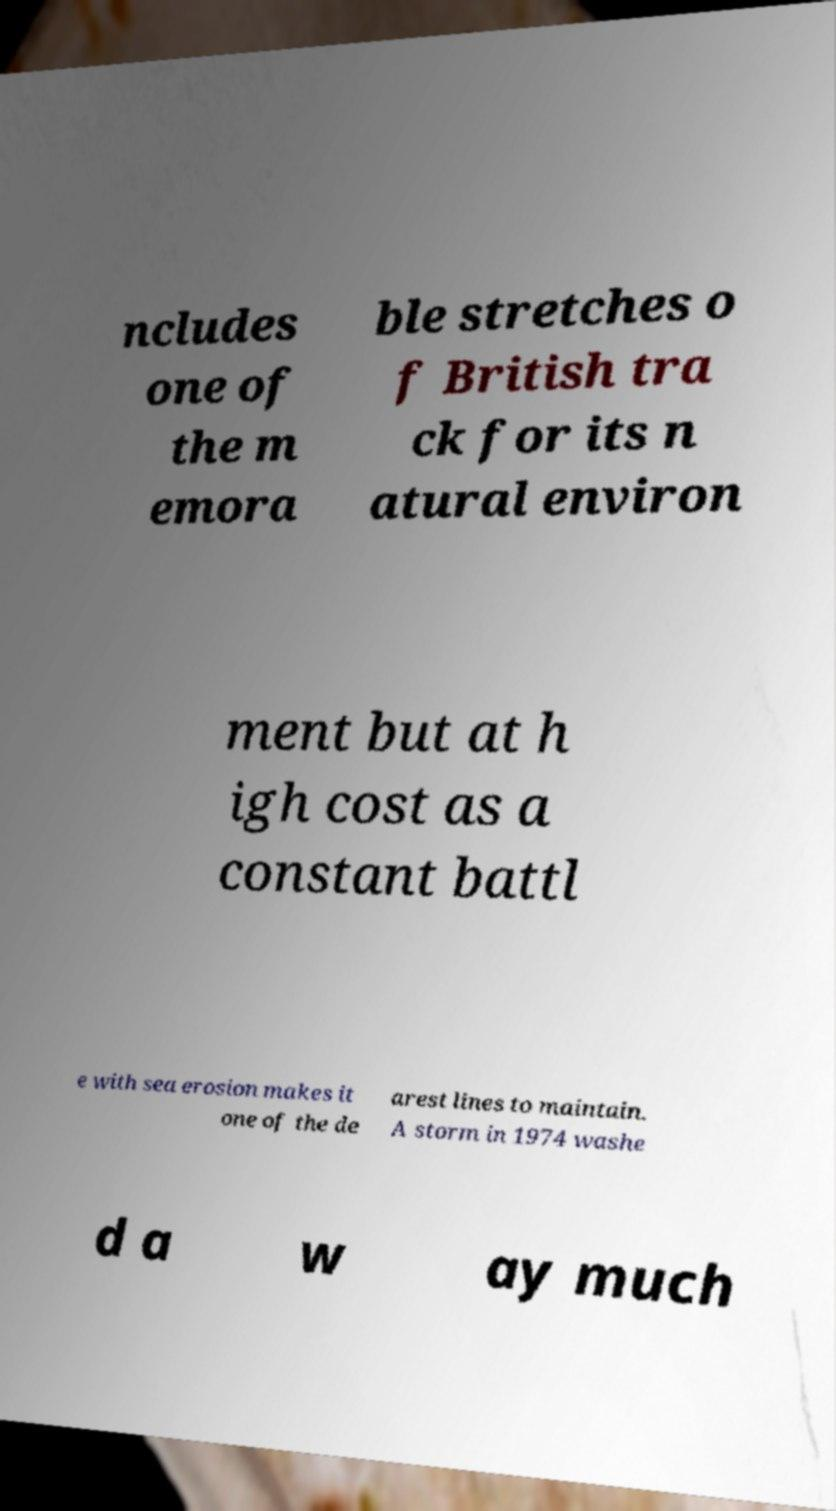There's text embedded in this image that I need extracted. Can you transcribe it verbatim? ncludes one of the m emora ble stretches o f British tra ck for its n atural environ ment but at h igh cost as a constant battl e with sea erosion makes it one of the de arest lines to maintain. A storm in 1974 washe d a w ay much 